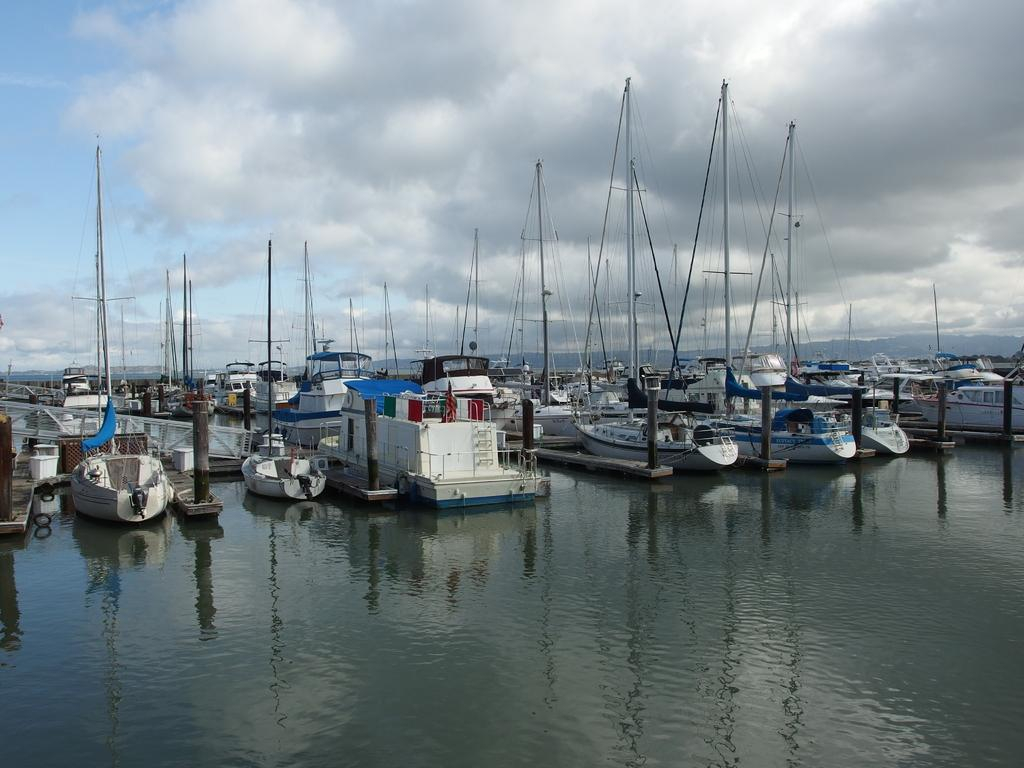What is the primary element in the image? There is water in the image. What is floating on the surface of the water? There are boats on the surface of the water. What can be seen in the background of the image? The sky is visible in the background of the image. Where is the home of the person wearing the badge in the image? There is no person wearing a badge present in the image. What type of whip can be seen in the image? There is no whip present in the image. 